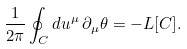Convert formula to latex. <formula><loc_0><loc_0><loc_500><loc_500>\frac { 1 } { 2 \pi } \oint _ { C } d u ^ { \mu } \, \partial _ { \mu } \theta = - L [ C ] .</formula> 